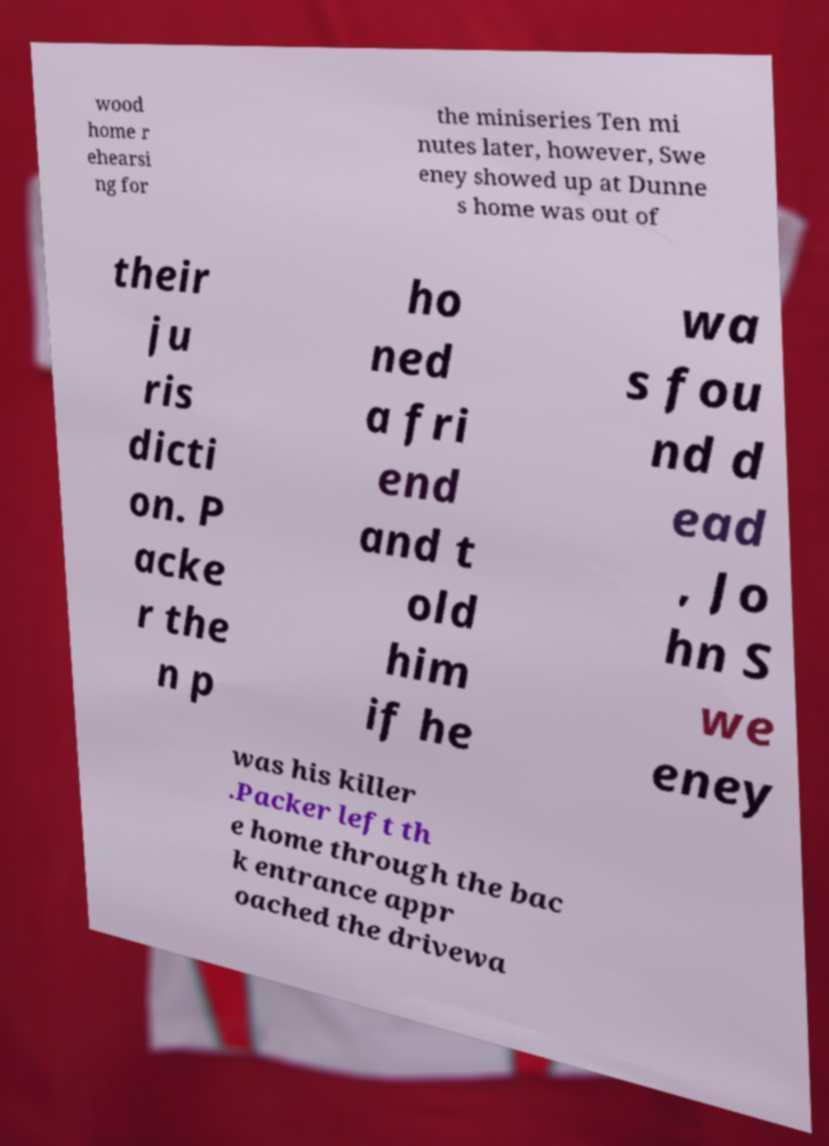Please identify and transcribe the text found in this image. wood home r ehearsi ng for the miniseries Ten mi nutes later, however, Swe eney showed up at Dunne s home was out of their ju ris dicti on. P acke r the n p ho ned a fri end and t old him if he wa s fou nd d ead , Jo hn S we eney was his killer .Packer left th e home through the bac k entrance appr oached the drivewa 